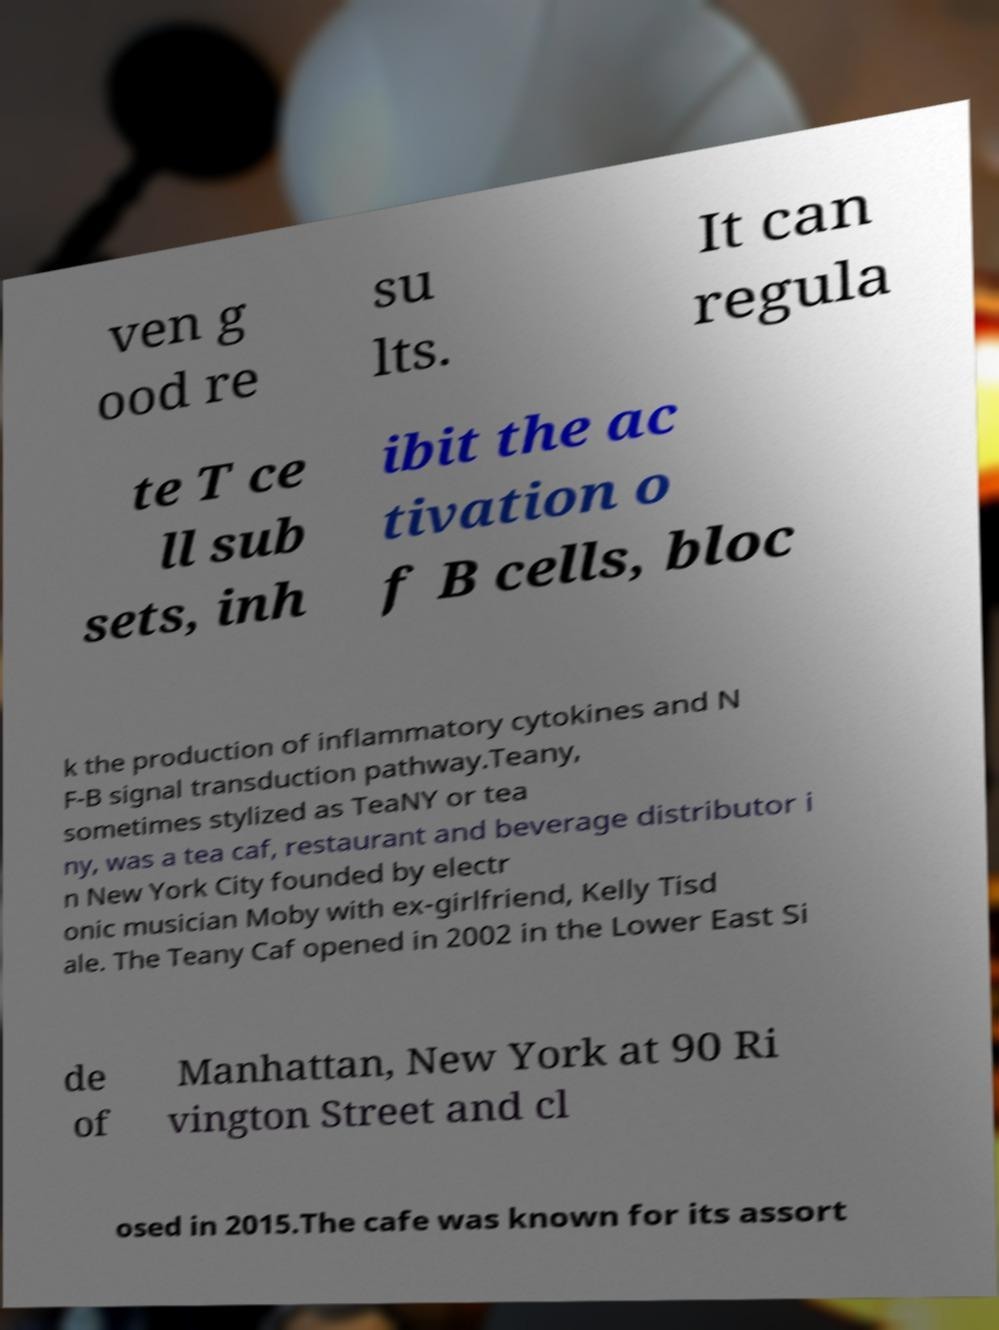For documentation purposes, I need the text within this image transcribed. Could you provide that? ven g ood re su lts. It can regula te T ce ll sub sets, inh ibit the ac tivation o f B cells, bloc k the production of inflammatory cytokines and N F-B signal transduction pathway.Teany, sometimes stylized as TeaNY or tea ny, was a tea caf, restaurant and beverage distributor i n New York City founded by electr onic musician Moby with ex-girlfriend, Kelly Tisd ale. The Teany Caf opened in 2002 in the Lower East Si de of Manhattan, New York at 90 Ri vington Street and cl osed in 2015.The cafe was known for its assort 